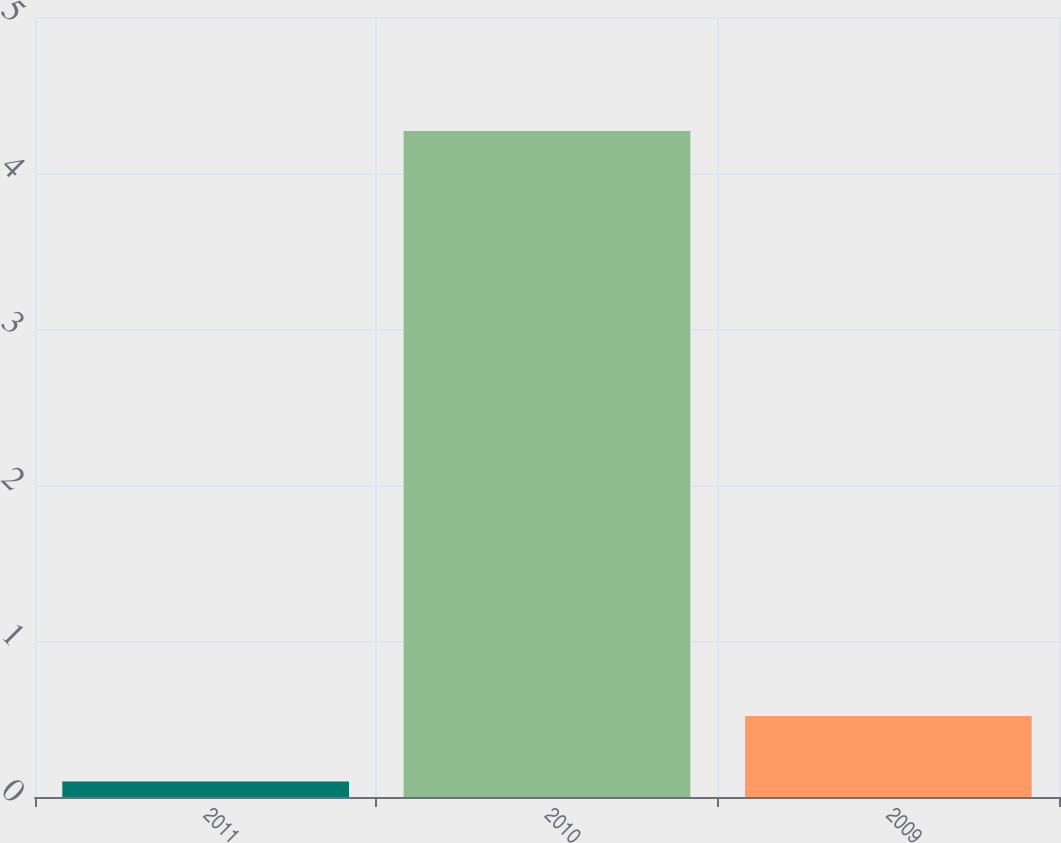Convert chart. <chart><loc_0><loc_0><loc_500><loc_500><bar_chart><fcel>2011<fcel>2010<fcel>2009<nl><fcel>0.1<fcel>4.27<fcel>0.52<nl></chart> 